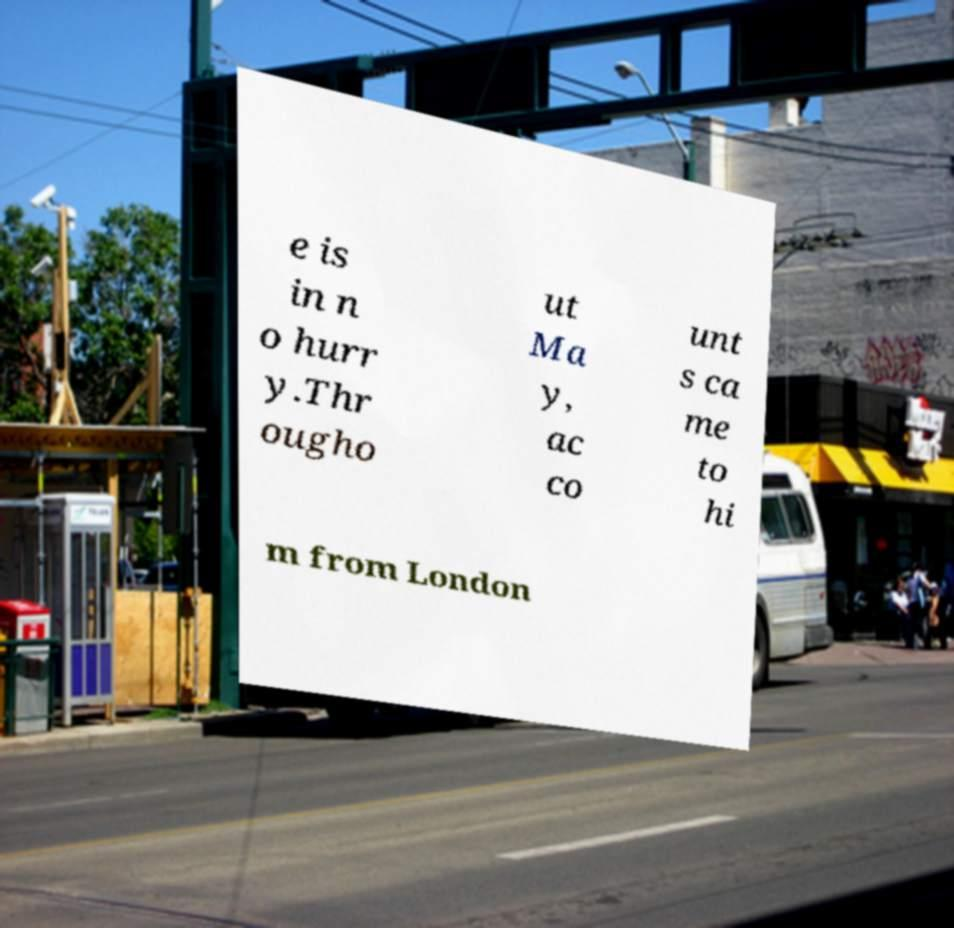What messages or text are displayed in this image? I need them in a readable, typed format. e is in n o hurr y.Thr ougho ut Ma y, ac co unt s ca me to hi m from London 